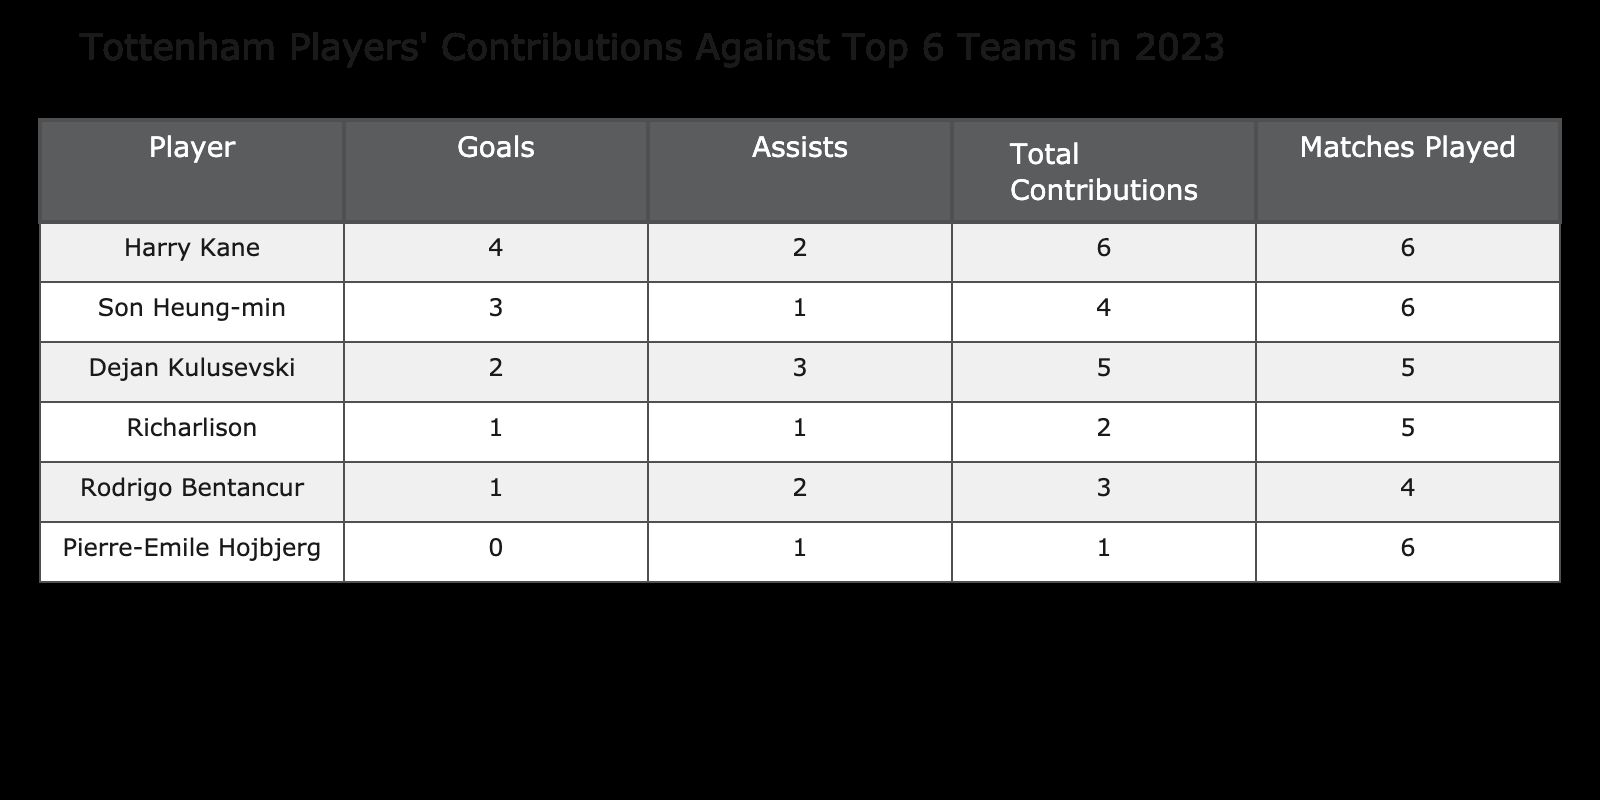What is the total number of goals scored by Tottenham players against top 6 teams in 2023? To find the total number of goals, I need to sum the 'Goals' column. Adding them up gives me 4 (Harry Kane) + 3 (Son Heung-min) + 2 (Dejan Kulusevski) + 1 (Richarlison) + 1 (Rodrigo Bentancur) + 0 (Pierre-Emile Hojbjerg) = 11 goals.
Answer: 11 Who has the highest number of assists among Tottenham players against top 6 teams? Looking at the 'Assists' column, I can see that Dejan Kulusevski has 3 assists, which is the highest compared to other players listed.
Answer: Dejan Kulusevski How many matches did Harry Kane play in 2023 against top 6 teams? Referring to the 'Matches Played' column next to Harry Kane's row shows that he played 6 matches against top 6 teams.
Answer: 6 What is the average number of total contributions (goals + assists) made by Tottenham players in 2023? To calculate the average total contributions, first sum each player's contributions: Harry Kane (6), Son Heung-min (4), Dejan Kulusevski (5), Richarlison (2), Rodrigo Bentancur (3), and Pierre-Emile Hojbjerg (1). The total is 21, and there are 6 players, so the average is 21/6 = 3.5.
Answer: 3.5 Is it true that Rodrigo Bentancur contributed more assists than goals against top 6 teams? Checking the contributions of Rodrigo Bentancur reveals that he has 1 assist and 1 goal. Since his assists are equal to his goals, the statement is false.
Answer: No What is the total number of contributions (goals + assists) that Richarlison made? Richarlison scored 1 goal and made 1 assist. Therefore, total contributions are 1 + 1 = 2 contributions.
Answer: 2 Who has the least total contributions against top 6 teams? To find this, I check the total contributions for each player. Pierre-Emile Hojbjerg has 1 contribution (0 goals + 1 assist), which is the least among all players.
Answer: Pierre-Emile Hojbjerg What percentage of goals scored by Tottenham players were contributed by Son Heung-min? First, calculate the number of goals he scored, which is 3. Then, using the total goals of 11, the percentage is (3/11) * 100 = 27.27%.
Answer: 27.27% How many players contributed both goals and assists against top 6 teams? By examining the table, I see that three players (Harry Kane, Son Heung-min, and Dejan Kulusevski) contributed both goals and assists.
Answer: 3 